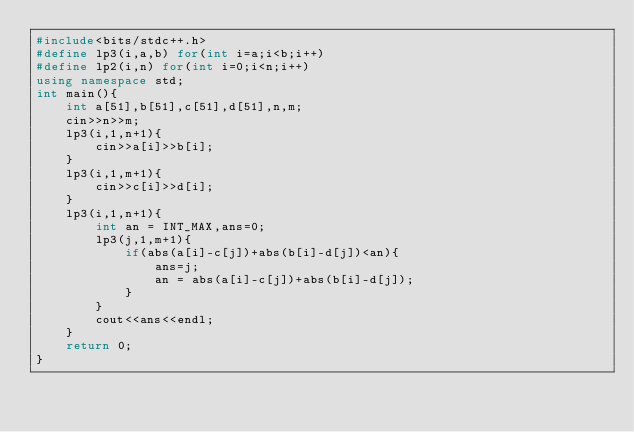Convert code to text. <code><loc_0><loc_0><loc_500><loc_500><_C++_>#include<bits/stdc++.h>
#define lp3(i,a,b) for(int i=a;i<b;i++)
#define lp2(i,n) for(int i=0;i<n;i++)
using namespace std;
int main(){
	int a[51],b[51],c[51],d[51],n,m;
	cin>>n>>m;
	lp3(i,1,n+1){
		cin>>a[i]>>b[i];
	}
	lp3(i,1,m+1){
		cin>>c[i]>>d[i];
	}
	lp3(i,1,n+1){
		int an = INT_MAX,ans=0;
		lp3(j,1,m+1){
			if(abs(a[i]-c[j])+abs(b[i]-d[j])<an){
				ans=j;
				an = abs(a[i]-c[j])+abs(b[i]-d[j]);
			}
		}
		cout<<ans<<endl;
	}
	return 0;
}
</code> 